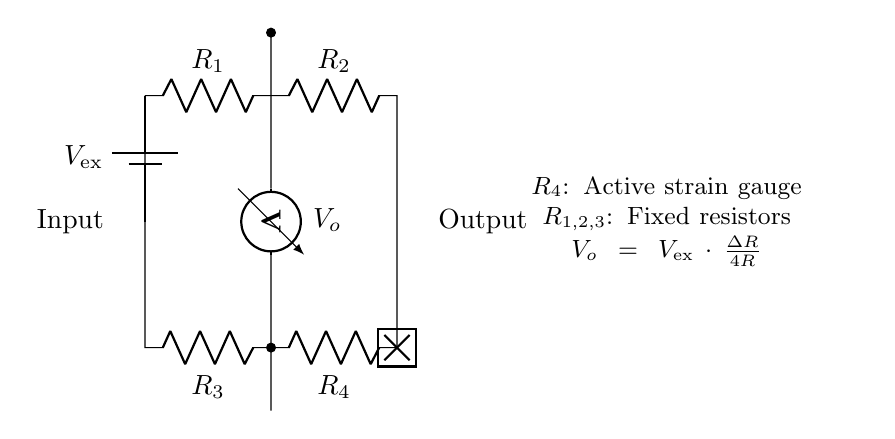What type of circuit is represented? The circuit is a strain gauge bridge, which is designed to measure changes in resistance due to strain on the structure. This can be inferred from the arrangement of the resistors and the inclusion of a strain gauge.
Answer: Strain gauge bridge What is the purpose of resistor R4? Resistor R4 serves as the active strain gauge in the bridge circuit, detecting the changes in resistance when the structure experiences strain. This is indicated in the diagram where R4 is labeled specifically as the active strain gauge.
Answer: Active strain gauge How many resistors are in this circuit? There are four resistors in total, labeled as R1, R2, R3, and R4, which are visible in the circuit diagram.
Answer: Four What is the formula for the output voltage V_o? The formula given for the output voltage V_o in the circuit is V_o = V_ex * (Delta R / 4R). Here, Delta R represents the change in resistance in the active strain gauge relative to the fixed resistors. This is described in the explanatory text beside the circuit diagram.
Answer: V_o = V_ex * (Delta R / 4R) If V_ex is 10V and Delta R is 1 Ohm, what would V_o be if each of the resistors has a resistance of 100 Ohms? Plugging the given values into the formula: V_o = 10 * (1 / (4 * 100)) = 10 * (1/400) = 0.025V. This requires using the formula and substituting the provided numbers.
Answer: 0.025V Which component measures the output voltage? The voltmeter is the component that measures the output voltage in the circuit diagram, as indicated by its label placed between two short connections.
Answer: Voltmeter 